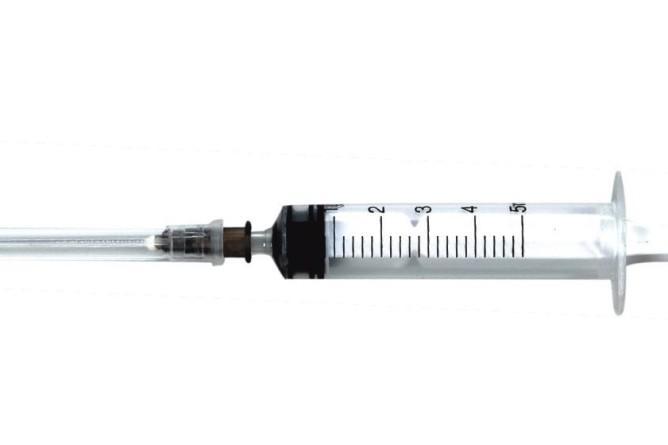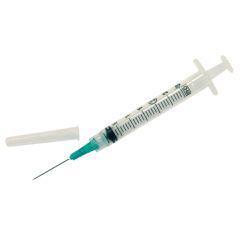The first image is the image on the left, the second image is the image on the right. Considering the images on both sides, is "Both syringes do not have the needle attached." valid? Answer yes or no. No. The first image is the image on the left, the second image is the image on the right. For the images displayed, is the sentence "Both images show syringes with needles attached." factually correct? Answer yes or no. Yes. 